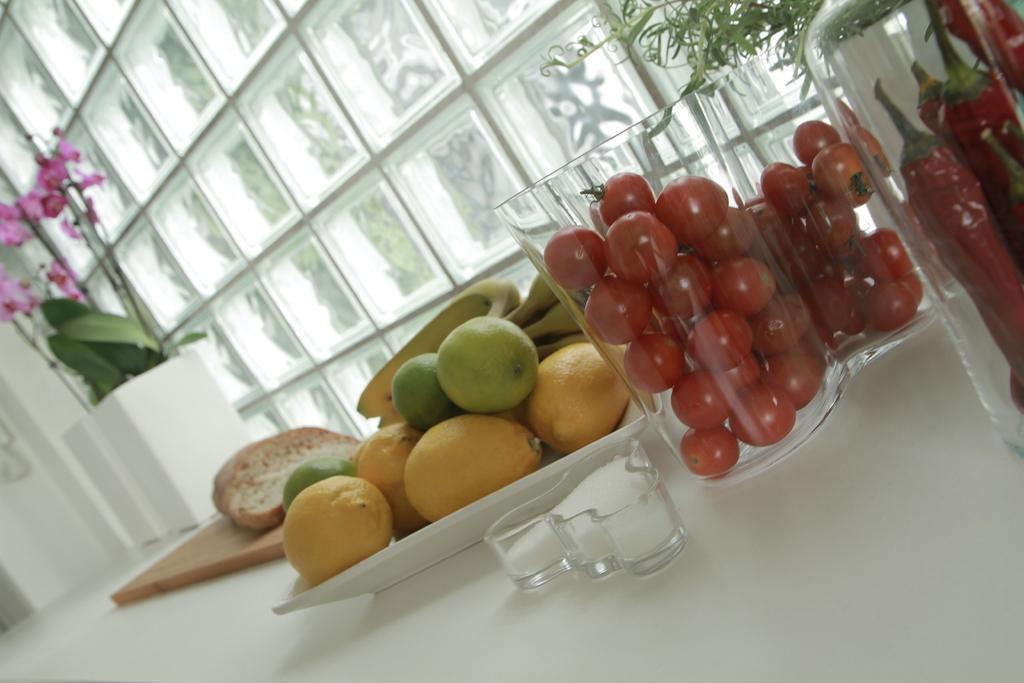Describe this image in one or two sentences. In this image I can see a white colored table and on it I an see a chopping board, a white colored plate, few fruits on the plate, a bread on the chopping board, few glasses in which I can see few fruits which are red in color and I can see a plant, few flowers which are pink in color and the glass windows. 